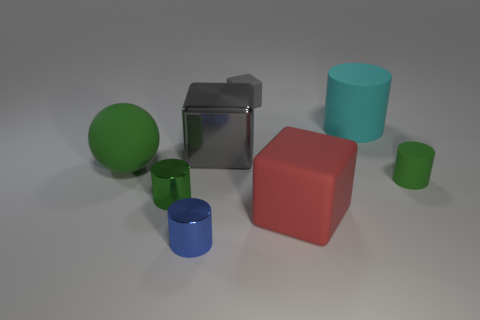Is the material of the tiny green thing in front of the green matte cylinder the same as the big gray cube?
Give a very brief answer. Yes. Is the number of large matte balls behind the cyan cylinder the same as the number of small gray matte things that are on the left side of the blue cylinder?
Your response must be concise. Yes. What size is the cylinder that is in front of the big red rubber cube?
Your answer should be very brief. Small. Are there any big green objects made of the same material as the red cube?
Provide a short and direct response. Yes. Do the small object behind the big green rubber object and the big metallic cube have the same color?
Keep it short and to the point. Yes. Is the number of green cylinders left of the green matte cylinder the same as the number of green rubber things?
Your answer should be compact. No. Are there any tiny rubber objects of the same color as the tiny rubber cylinder?
Give a very brief answer. No. Do the green shiny thing and the gray rubber thing have the same size?
Provide a succinct answer. Yes. How big is the green object that is behind the cylinder that is on the right side of the cyan object?
Provide a succinct answer. Large. How big is the object that is both on the left side of the cyan object and behind the gray metal cube?
Offer a terse response. Small. 